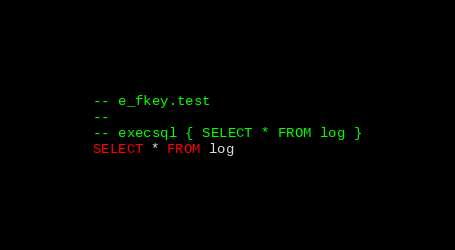Convert code to text. <code><loc_0><loc_0><loc_500><loc_500><_SQL_>-- e_fkey.test
-- 
-- execsql { SELECT * FROM log }
SELECT * FROM log</code> 